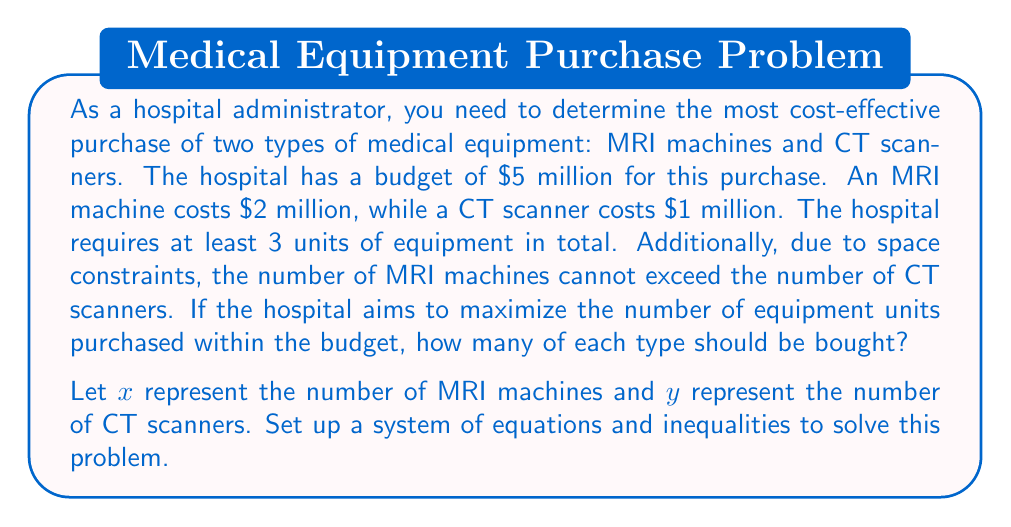Solve this math problem. To solve this problem, we need to set up a system of equations and inequalities based on the given constraints:

1. Budget constraint: 
   $$2x + y = 5$$ (in millions of dollars)

2. Total equipment constraint:
   $$x + y \geq 3$$

3. Space constraint:
   $$x \leq y$$

4. Non-negativity constraints:
   $$x \geq 0, y \geq 0$$

5. Integer constraint (as we can't buy fractional equipment):
   $x$ and $y$ must be integers

To maximize the number of equipment units, we need to maximize $x + y$ subject to these constraints.

Let's solve this graphically:

1. Plot the budget constraint: $y = 5 - 2x$
2. The feasible region is bounded by $x + y \geq 3$, $x \leq y$, and the axes.
3. The integer points within this region that satisfy the budget constraint are:
   (0, 5), (1, 3), and (2, 1)

Among these points:
- (0, 5) gives 5 total units
- (1, 3) gives 4 total units
- (2, 1) gives 3 total units

Therefore, the optimal solution is (1, 3), meaning 1 MRI machine and 3 CT scanners.

This solution satisfies all constraints:
- Budget: $2(1) + 1(3) = 5$ million
- Total equipment: $1 + 3 = 4 \geq 3$
- Space: $1 \leq 3$
- Non-negativity and integer constraints are met
Answer: The hospital should purchase 1 MRI machine and 3 CT scanners to maximize the number of equipment units within the given constraints. 